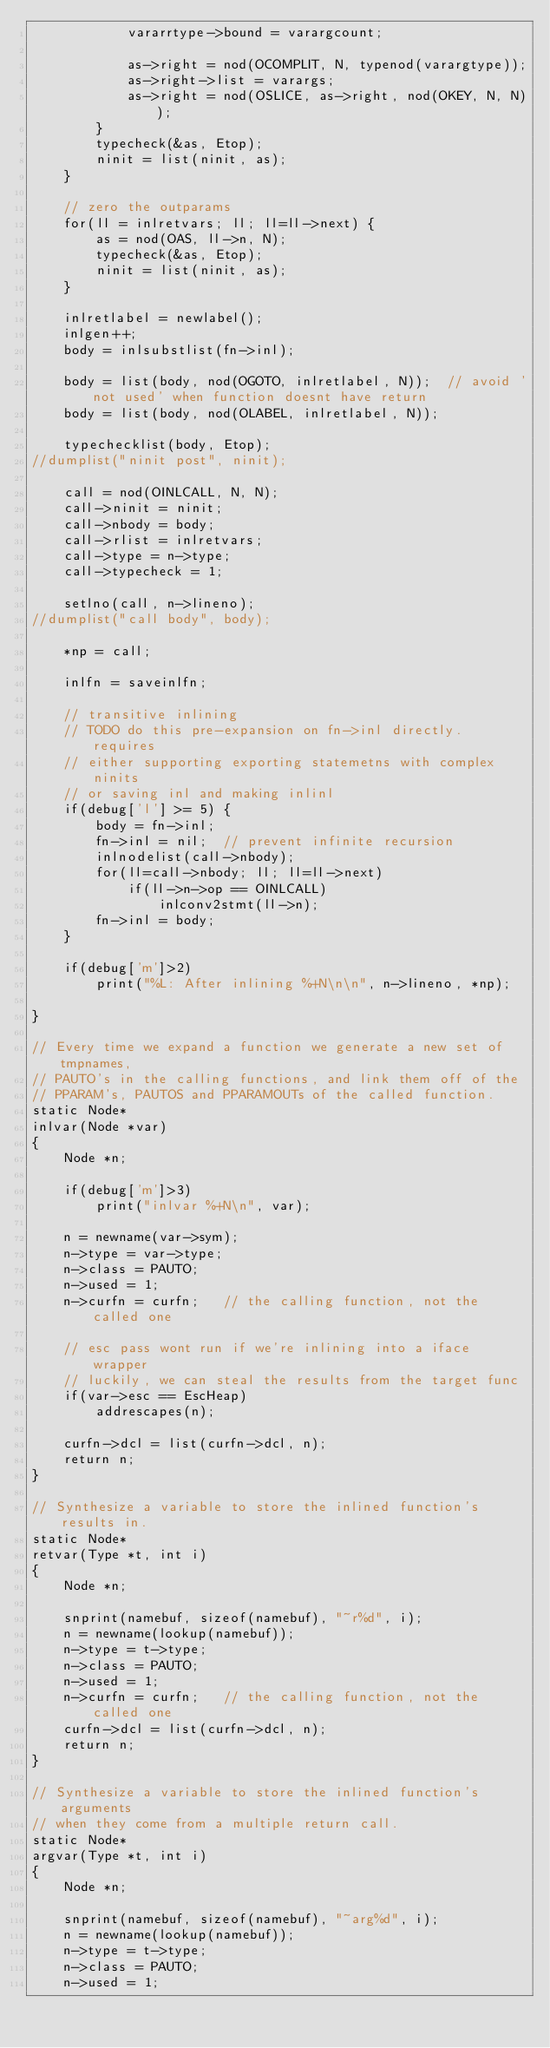<code> <loc_0><loc_0><loc_500><loc_500><_C_>			vararrtype->bound = varargcount;

			as->right = nod(OCOMPLIT, N, typenod(varargtype));
			as->right->list = varargs;
			as->right = nod(OSLICE, as->right, nod(OKEY, N, N));
		}
		typecheck(&as, Etop);
		ninit = list(ninit, as);
	}

	// zero the outparams
	for(ll = inlretvars; ll; ll=ll->next) {
		as = nod(OAS, ll->n, N);
		typecheck(&as, Etop);
		ninit = list(ninit, as);
	}

	inlretlabel = newlabel();
	inlgen++;
	body = inlsubstlist(fn->inl);

	body = list(body, nod(OGOTO, inlretlabel, N));	// avoid 'not used' when function doesnt have return
	body = list(body, nod(OLABEL, inlretlabel, N));

	typechecklist(body, Etop);
//dumplist("ninit post", ninit);

	call = nod(OINLCALL, N, N);
	call->ninit = ninit;
	call->nbody = body;
	call->rlist = inlretvars;
	call->type = n->type;
	call->typecheck = 1;

	setlno(call, n->lineno);
//dumplist("call body", body);

	*np = call;

	inlfn =	saveinlfn;

	// transitive inlining
	// TODO do this pre-expansion on fn->inl directly.  requires
	// either supporting exporting statemetns with complex ninits
	// or saving inl and making inlinl
	if(debug['l'] >= 5) {
		body = fn->inl;
		fn->inl = nil;	// prevent infinite recursion
		inlnodelist(call->nbody);
		for(ll=call->nbody; ll; ll=ll->next)
			if(ll->n->op == OINLCALL)
				inlconv2stmt(ll->n);
		fn->inl = body;
	}

	if(debug['m']>2)
		print("%L: After inlining %+N\n\n", n->lineno, *np);

}

// Every time we expand a function we generate a new set of tmpnames,
// PAUTO's in the calling functions, and link them off of the
// PPARAM's, PAUTOS and PPARAMOUTs of the called function. 
static Node*
inlvar(Node *var)
{
	Node *n;

	if(debug['m']>3)
		print("inlvar %+N\n", var);

	n = newname(var->sym);
	n->type = var->type;
	n->class = PAUTO;
	n->used = 1;
	n->curfn = curfn;   // the calling function, not the called one

	// esc pass wont run if we're inlining into a iface wrapper
	// luckily, we can steal the results from the target func
	if(var->esc == EscHeap)
		addrescapes(n);

	curfn->dcl = list(curfn->dcl, n);
	return n;
}

// Synthesize a variable to store the inlined function's results in.
static Node*
retvar(Type *t, int i)
{
	Node *n;

	snprint(namebuf, sizeof(namebuf), "~r%d", i);
	n = newname(lookup(namebuf));
	n->type = t->type;
	n->class = PAUTO;
	n->used = 1;
	n->curfn = curfn;   // the calling function, not the called one
	curfn->dcl = list(curfn->dcl, n);
	return n;
}

// Synthesize a variable to store the inlined function's arguments
// when they come from a multiple return call.
static Node*
argvar(Type *t, int i)
{
	Node *n;

	snprint(namebuf, sizeof(namebuf), "~arg%d", i);
	n = newname(lookup(namebuf));
	n->type = t->type;
	n->class = PAUTO;
	n->used = 1;</code> 